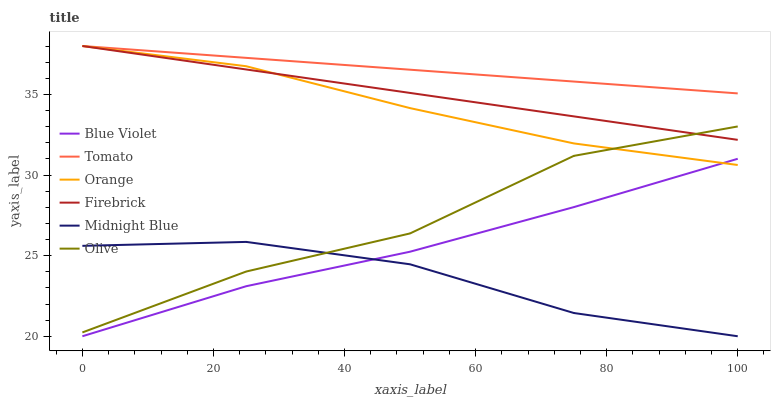Does Firebrick have the minimum area under the curve?
Answer yes or no. No. Does Firebrick have the maximum area under the curve?
Answer yes or no. No. Is Midnight Blue the smoothest?
Answer yes or no. No. Is Midnight Blue the roughest?
Answer yes or no. No. Does Firebrick have the lowest value?
Answer yes or no. No. Does Midnight Blue have the highest value?
Answer yes or no. No. Is Midnight Blue less than Tomato?
Answer yes or no. Yes. Is Firebrick greater than Blue Violet?
Answer yes or no. Yes. Does Midnight Blue intersect Tomato?
Answer yes or no. No. 